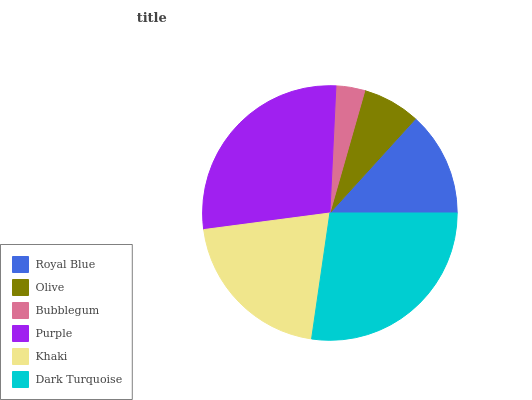Is Bubblegum the minimum?
Answer yes or no. Yes. Is Purple the maximum?
Answer yes or no. Yes. Is Olive the minimum?
Answer yes or no. No. Is Olive the maximum?
Answer yes or no. No. Is Royal Blue greater than Olive?
Answer yes or no. Yes. Is Olive less than Royal Blue?
Answer yes or no. Yes. Is Olive greater than Royal Blue?
Answer yes or no. No. Is Royal Blue less than Olive?
Answer yes or no. No. Is Khaki the high median?
Answer yes or no. Yes. Is Royal Blue the low median?
Answer yes or no. Yes. Is Dark Turquoise the high median?
Answer yes or no. No. Is Olive the low median?
Answer yes or no. No. 